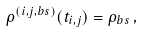Convert formula to latex. <formula><loc_0><loc_0><loc_500><loc_500>\rho ^ { ( i , j , b s ) } ( t _ { i , j } ) = \rho _ { b s } \, ,</formula> 